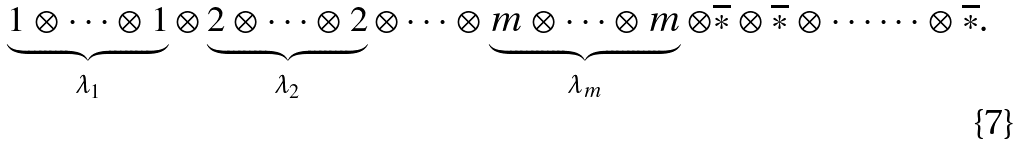Convert formula to latex. <formula><loc_0><loc_0><loc_500><loc_500>\underbrace { 1 \otimes \cdots \otimes 1 } _ { \lambda _ { 1 } } \otimes \underbrace { 2 \otimes \cdots \otimes 2 } _ { \lambda _ { 2 } } \otimes \cdots \otimes \underbrace { m \otimes \cdots \otimes m } _ { \lambda _ { m } } \otimes \overline { * } \otimes \overline { * } \otimes \cdots \cdots \otimes \overline { * } .</formula> 